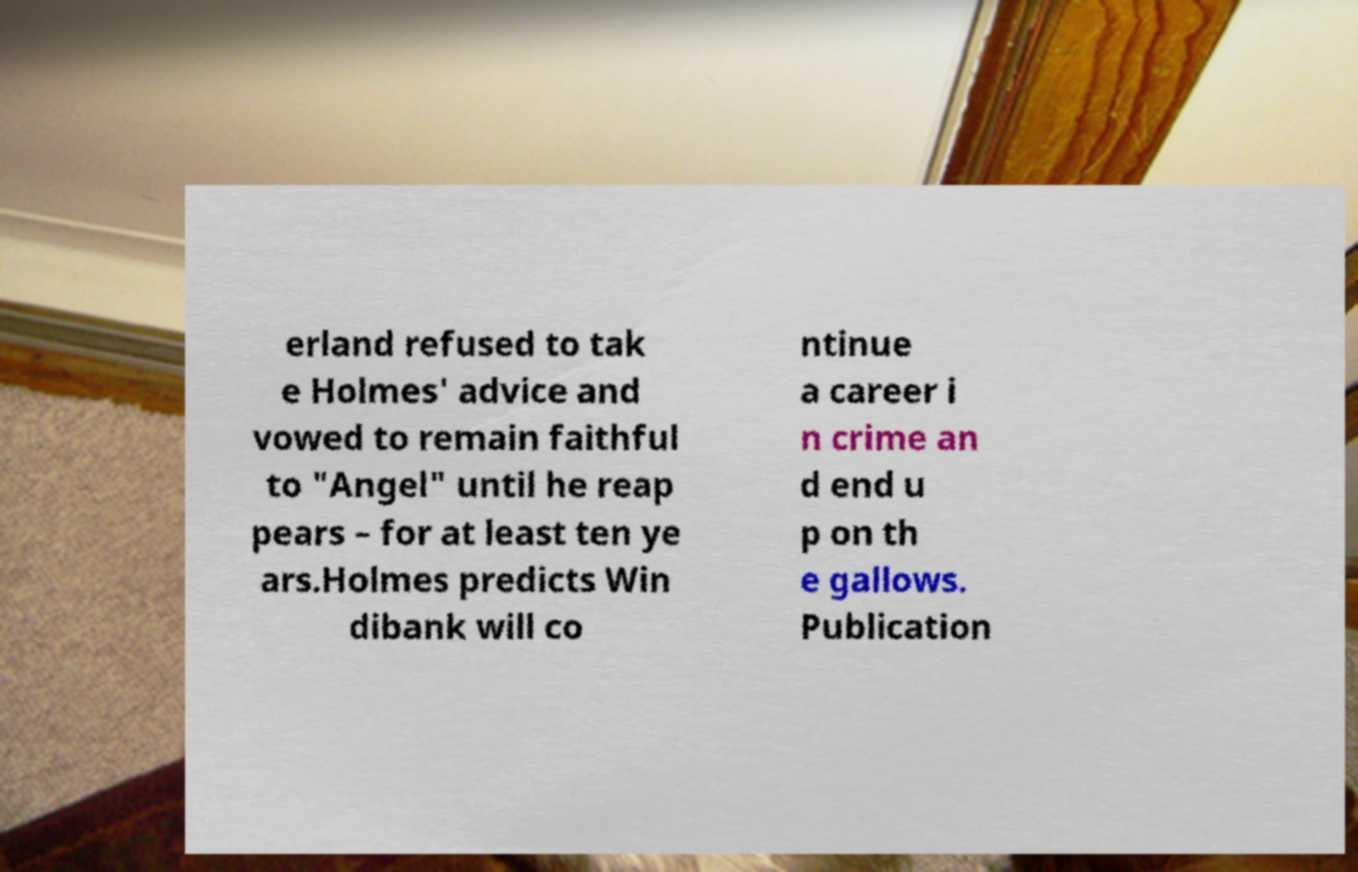Could you extract and type out the text from this image? erland refused to tak e Holmes' advice and vowed to remain faithful to "Angel" until he reap pears – for at least ten ye ars.Holmes predicts Win dibank will co ntinue a career i n crime an d end u p on th e gallows. Publication 